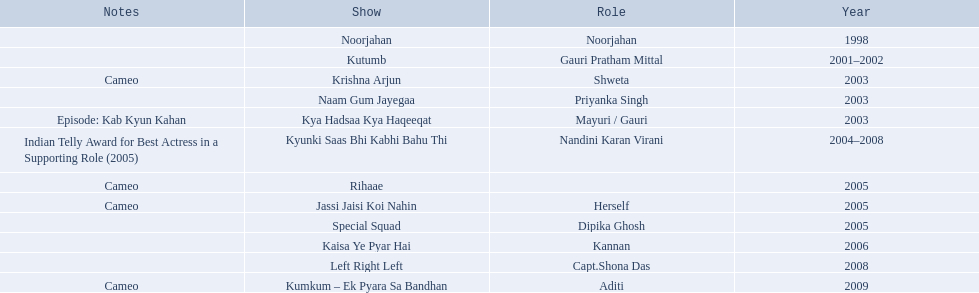In 1998 what was the role of gauri pradhan tejwani? Noorjahan. In 2003 what show did gauri have a cameo in? Krishna Arjun. Gauri was apart of which television show for the longest? Kyunki Saas Bhi Kabhi Bahu Thi. 